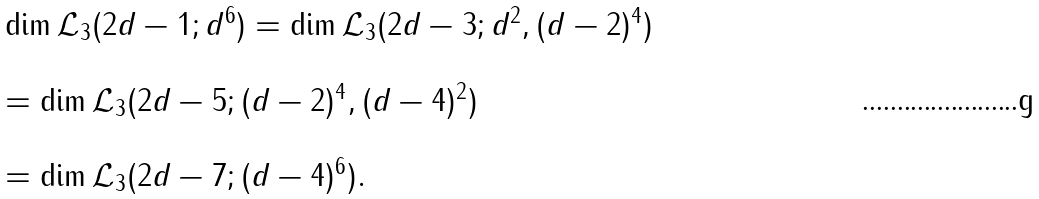<formula> <loc_0><loc_0><loc_500><loc_500>\begin{array} { l } \dim { \mathcal { L } _ { 3 } } ( 2 d - 1 ; d ^ { 6 } ) = \dim { \mathcal { L } _ { 3 } } ( 2 d - 3 ; d ^ { 2 } , ( d - 2 ) ^ { 4 } ) \\ \\ = \dim { \mathcal { L } _ { 3 } } ( 2 d - 5 ; ( d - 2 ) ^ { 4 } , ( d - 4 ) ^ { 2 } ) \\ \\ = \dim { \mathcal { L } _ { 3 } } ( 2 d - 7 ; ( d - 4 ) ^ { 6 } ) . \end{array}</formula> 